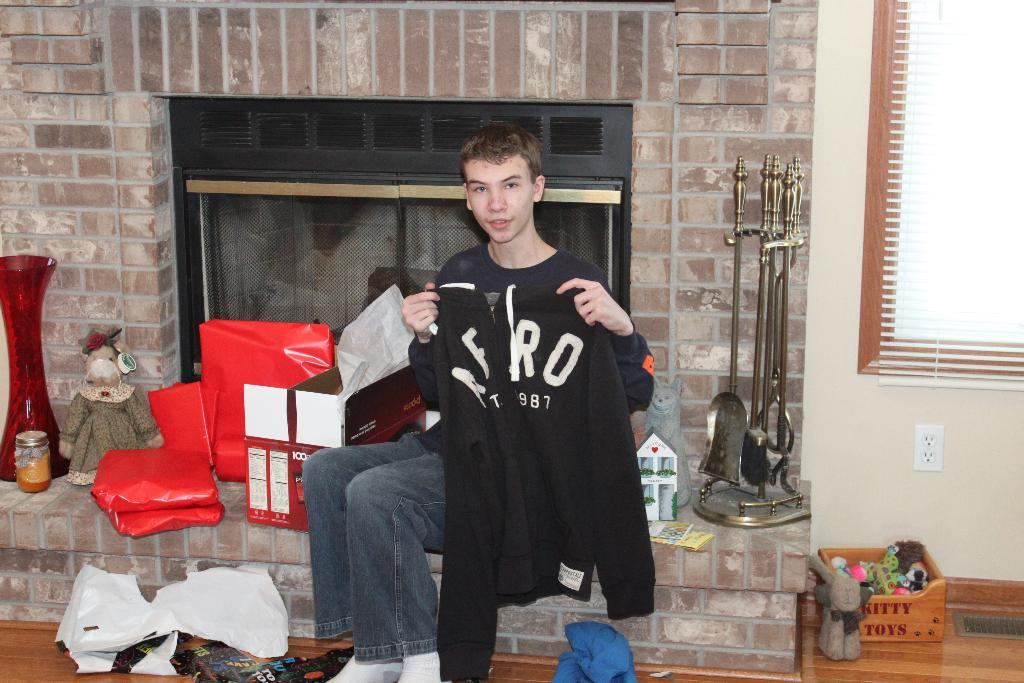Provide a one-sentence caption for the provided image. A man poses with his Aero sweater in front of a fireplace. 